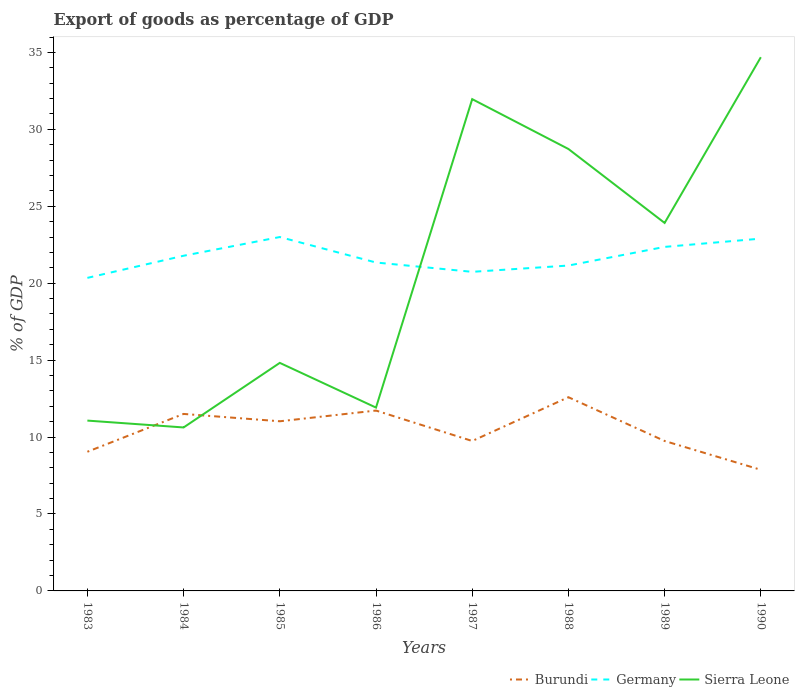How many different coloured lines are there?
Your answer should be compact. 3. Across all years, what is the maximum export of goods as percentage of GDP in Burundi?
Offer a very short reply. 7.87. In which year was the export of goods as percentage of GDP in Burundi maximum?
Your answer should be compact. 1990. What is the total export of goods as percentage of GDP in Germany in the graph?
Keep it short and to the point. -0.58. What is the difference between the highest and the second highest export of goods as percentage of GDP in Sierra Leone?
Provide a succinct answer. 24.07. Is the export of goods as percentage of GDP in Sierra Leone strictly greater than the export of goods as percentage of GDP in Burundi over the years?
Give a very brief answer. No. How many years are there in the graph?
Provide a succinct answer. 8. What is the title of the graph?
Your answer should be very brief. Export of goods as percentage of GDP. Does "Luxembourg" appear as one of the legend labels in the graph?
Ensure brevity in your answer.  No. What is the label or title of the Y-axis?
Provide a short and direct response. % of GDP. What is the % of GDP of Burundi in 1983?
Your answer should be compact. 9.05. What is the % of GDP of Germany in 1983?
Give a very brief answer. 20.35. What is the % of GDP in Sierra Leone in 1983?
Offer a very short reply. 11.07. What is the % of GDP of Burundi in 1984?
Provide a short and direct response. 11.5. What is the % of GDP of Germany in 1984?
Provide a succinct answer. 21.79. What is the % of GDP in Sierra Leone in 1984?
Make the answer very short. 10.62. What is the % of GDP of Burundi in 1985?
Give a very brief answer. 11.03. What is the % of GDP in Germany in 1985?
Your answer should be compact. 23. What is the % of GDP of Sierra Leone in 1985?
Ensure brevity in your answer.  14.82. What is the % of GDP in Burundi in 1986?
Offer a very short reply. 11.72. What is the % of GDP of Germany in 1986?
Your answer should be very brief. 21.35. What is the % of GDP in Sierra Leone in 1986?
Your answer should be very brief. 11.92. What is the % of GDP of Burundi in 1987?
Ensure brevity in your answer.  9.74. What is the % of GDP in Germany in 1987?
Provide a short and direct response. 20.74. What is the % of GDP of Sierra Leone in 1987?
Keep it short and to the point. 31.96. What is the % of GDP of Burundi in 1988?
Your answer should be very brief. 12.59. What is the % of GDP of Germany in 1988?
Offer a very short reply. 21.15. What is the % of GDP in Sierra Leone in 1988?
Your answer should be compact. 28.72. What is the % of GDP in Burundi in 1989?
Keep it short and to the point. 9.75. What is the % of GDP in Germany in 1989?
Your answer should be very brief. 22.36. What is the % of GDP of Sierra Leone in 1989?
Make the answer very short. 23.92. What is the % of GDP in Burundi in 1990?
Make the answer very short. 7.87. What is the % of GDP of Germany in 1990?
Provide a succinct answer. 22.9. What is the % of GDP in Sierra Leone in 1990?
Keep it short and to the point. 34.69. Across all years, what is the maximum % of GDP in Burundi?
Offer a very short reply. 12.59. Across all years, what is the maximum % of GDP of Germany?
Ensure brevity in your answer.  23. Across all years, what is the maximum % of GDP in Sierra Leone?
Ensure brevity in your answer.  34.69. Across all years, what is the minimum % of GDP in Burundi?
Provide a short and direct response. 7.87. Across all years, what is the minimum % of GDP of Germany?
Keep it short and to the point. 20.35. Across all years, what is the minimum % of GDP in Sierra Leone?
Give a very brief answer. 10.62. What is the total % of GDP in Burundi in the graph?
Offer a terse response. 83.25. What is the total % of GDP in Germany in the graph?
Ensure brevity in your answer.  173.63. What is the total % of GDP in Sierra Leone in the graph?
Keep it short and to the point. 167.73. What is the difference between the % of GDP of Burundi in 1983 and that in 1984?
Provide a succinct answer. -2.46. What is the difference between the % of GDP of Germany in 1983 and that in 1984?
Your response must be concise. -1.44. What is the difference between the % of GDP in Sierra Leone in 1983 and that in 1984?
Your response must be concise. 0.45. What is the difference between the % of GDP in Burundi in 1983 and that in 1985?
Make the answer very short. -1.98. What is the difference between the % of GDP in Germany in 1983 and that in 1985?
Offer a very short reply. -2.65. What is the difference between the % of GDP of Sierra Leone in 1983 and that in 1985?
Provide a succinct answer. -3.75. What is the difference between the % of GDP of Burundi in 1983 and that in 1986?
Give a very brief answer. -2.68. What is the difference between the % of GDP of Germany in 1983 and that in 1986?
Offer a very short reply. -1. What is the difference between the % of GDP in Sierra Leone in 1983 and that in 1986?
Keep it short and to the point. -0.85. What is the difference between the % of GDP of Burundi in 1983 and that in 1987?
Offer a very short reply. -0.7. What is the difference between the % of GDP in Germany in 1983 and that in 1987?
Offer a very short reply. -0.39. What is the difference between the % of GDP in Sierra Leone in 1983 and that in 1987?
Make the answer very short. -20.89. What is the difference between the % of GDP in Burundi in 1983 and that in 1988?
Your response must be concise. -3.55. What is the difference between the % of GDP in Germany in 1983 and that in 1988?
Your response must be concise. -0.8. What is the difference between the % of GDP in Sierra Leone in 1983 and that in 1988?
Offer a terse response. -17.65. What is the difference between the % of GDP in Burundi in 1983 and that in 1989?
Ensure brevity in your answer.  -0.7. What is the difference between the % of GDP in Germany in 1983 and that in 1989?
Offer a very short reply. -2.01. What is the difference between the % of GDP of Sierra Leone in 1983 and that in 1989?
Offer a very short reply. -12.85. What is the difference between the % of GDP in Burundi in 1983 and that in 1990?
Offer a very short reply. 1.17. What is the difference between the % of GDP in Germany in 1983 and that in 1990?
Offer a very short reply. -2.55. What is the difference between the % of GDP in Sierra Leone in 1983 and that in 1990?
Your response must be concise. -23.62. What is the difference between the % of GDP of Burundi in 1984 and that in 1985?
Offer a very short reply. 0.48. What is the difference between the % of GDP in Germany in 1984 and that in 1985?
Offer a terse response. -1.22. What is the difference between the % of GDP in Sierra Leone in 1984 and that in 1985?
Your answer should be compact. -4.2. What is the difference between the % of GDP in Burundi in 1984 and that in 1986?
Keep it short and to the point. -0.22. What is the difference between the % of GDP of Germany in 1984 and that in 1986?
Ensure brevity in your answer.  0.44. What is the difference between the % of GDP of Sierra Leone in 1984 and that in 1986?
Keep it short and to the point. -1.29. What is the difference between the % of GDP in Burundi in 1984 and that in 1987?
Make the answer very short. 1.76. What is the difference between the % of GDP in Germany in 1984 and that in 1987?
Offer a very short reply. 1.05. What is the difference between the % of GDP of Sierra Leone in 1984 and that in 1987?
Your answer should be compact. -21.34. What is the difference between the % of GDP in Burundi in 1984 and that in 1988?
Make the answer very short. -1.09. What is the difference between the % of GDP of Germany in 1984 and that in 1988?
Your answer should be compact. 0.64. What is the difference between the % of GDP of Sierra Leone in 1984 and that in 1988?
Your answer should be compact. -18.1. What is the difference between the % of GDP of Burundi in 1984 and that in 1989?
Provide a succinct answer. 1.76. What is the difference between the % of GDP of Germany in 1984 and that in 1989?
Your answer should be very brief. -0.58. What is the difference between the % of GDP in Sierra Leone in 1984 and that in 1989?
Keep it short and to the point. -13.29. What is the difference between the % of GDP of Burundi in 1984 and that in 1990?
Your response must be concise. 3.63. What is the difference between the % of GDP of Germany in 1984 and that in 1990?
Ensure brevity in your answer.  -1.11. What is the difference between the % of GDP of Sierra Leone in 1984 and that in 1990?
Provide a succinct answer. -24.07. What is the difference between the % of GDP of Burundi in 1985 and that in 1986?
Provide a succinct answer. -0.7. What is the difference between the % of GDP of Germany in 1985 and that in 1986?
Make the answer very short. 1.66. What is the difference between the % of GDP in Sierra Leone in 1985 and that in 1986?
Your answer should be compact. 2.91. What is the difference between the % of GDP in Burundi in 1985 and that in 1987?
Ensure brevity in your answer.  1.28. What is the difference between the % of GDP of Germany in 1985 and that in 1987?
Offer a terse response. 2.26. What is the difference between the % of GDP of Sierra Leone in 1985 and that in 1987?
Your response must be concise. -17.14. What is the difference between the % of GDP in Burundi in 1985 and that in 1988?
Give a very brief answer. -1.56. What is the difference between the % of GDP of Germany in 1985 and that in 1988?
Keep it short and to the point. 1.85. What is the difference between the % of GDP in Sierra Leone in 1985 and that in 1988?
Your response must be concise. -13.9. What is the difference between the % of GDP of Burundi in 1985 and that in 1989?
Your answer should be very brief. 1.28. What is the difference between the % of GDP in Germany in 1985 and that in 1989?
Your answer should be compact. 0.64. What is the difference between the % of GDP of Sierra Leone in 1985 and that in 1989?
Give a very brief answer. -9.1. What is the difference between the % of GDP in Burundi in 1985 and that in 1990?
Keep it short and to the point. 3.15. What is the difference between the % of GDP of Germany in 1985 and that in 1990?
Give a very brief answer. 0.1. What is the difference between the % of GDP in Sierra Leone in 1985 and that in 1990?
Your answer should be compact. -19.87. What is the difference between the % of GDP of Burundi in 1986 and that in 1987?
Keep it short and to the point. 1.98. What is the difference between the % of GDP of Germany in 1986 and that in 1987?
Ensure brevity in your answer.  0.61. What is the difference between the % of GDP in Sierra Leone in 1986 and that in 1987?
Your answer should be very brief. -20.05. What is the difference between the % of GDP in Burundi in 1986 and that in 1988?
Ensure brevity in your answer.  -0.87. What is the difference between the % of GDP of Germany in 1986 and that in 1988?
Your answer should be compact. 0.2. What is the difference between the % of GDP in Sierra Leone in 1986 and that in 1988?
Keep it short and to the point. -16.81. What is the difference between the % of GDP of Burundi in 1986 and that in 1989?
Make the answer very short. 1.98. What is the difference between the % of GDP in Germany in 1986 and that in 1989?
Your answer should be very brief. -1.02. What is the difference between the % of GDP of Sierra Leone in 1986 and that in 1989?
Offer a terse response. -12. What is the difference between the % of GDP of Burundi in 1986 and that in 1990?
Your response must be concise. 3.85. What is the difference between the % of GDP in Germany in 1986 and that in 1990?
Ensure brevity in your answer.  -1.55. What is the difference between the % of GDP of Sierra Leone in 1986 and that in 1990?
Ensure brevity in your answer.  -22.77. What is the difference between the % of GDP in Burundi in 1987 and that in 1988?
Provide a short and direct response. -2.85. What is the difference between the % of GDP in Germany in 1987 and that in 1988?
Offer a very short reply. -0.41. What is the difference between the % of GDP in Sierra Leone in 1987 and that in 1988?
Make the answer very short. 3.24. What is the difference between the % of GDP in Burundi in 1987 and that in 1989?
Keep it short and to the point. -0. What is the difference between the % of GDP in Germany in 1987 and that in 1989?
Your answer should be very brief. -1.62. What is the difference between the % of GDP in Sierra Leone in 1987 and that in 1989?
Ensure brevity in your answer.  8.05. What is the difference between the % of GDP of Burundi in 1987 and that in 1990?
Your answer should be very brief. 1.87. What is the difference between the % of GDP in Germany in 1987 and that in 1990?
Your answer should be compact. -2.16. What is the difference between the % of GDP of Sierra Leone in 1987 and that in 1990?
Your answer should be very brief. -2.73. What is the difference between the % of GDP in Burundi in 1988 and that in 1989?
Ensure brevity in your answer.  2.85. What is the difference between the % of GDP of Germany in 1988 and that in 1989?
Offer a very short reply. -1.21. What is the difference between the % of GDP in Sierra Leone in 1988 and that in 1989?
Your response must be concise. 4.81. What is the difference between the % of GDP in Burundi in 1988 and that in 1990?
Give a very brief answer. 4.72. What is the difference between the % of GDP of Germany in 1988 and that in 1990?
Offer a terse response. -1.75. What is the difference between the % of GDP of Sierra Leone in 1988 and that in 1990?
Give a very brief answer. -5.97. What is the difference between the % of GDP of Burundi in 1989 and that in 1990?
Make the answer very short. 1.87. What is the difference between the % of GDP in Germany in 1989 and that in 1990?
Your response must be concise. -0.54. What is the difference between the % of GDP of Sierra Leone in 1989 and that in 1990?
Provide a succinct answer. -10.77. What is the difference between the % of GDP of Burundi in 1983 and the % of GDP of Germany in 1984?
Your response must be concise. -12.74. What is the difference between the % of GDP of Burundi in 1983 and the % of GDP of Sierra Leone in 1984?
Offer a terse response. -1.58. What is the difference between the % of GDP in Germany in 1983 and the % of GDP in Sierra Leone in 1984?
Offer a terse response. 9.72. What is the difference between the % of GDP of Burundi in 1983 and the % of GDP of Germany in 1985?
Offer a very short reply. -13.96. What is the difference between the % of GDP in Burundi in 1983 and the % of GDP in Sierra Leone in 1985?
Keep it short and to the point. -5.78. What is the difference between the % of GDP of Germany in 1983 and the % of GDP of Sierra Leone in 1985?
Your answer should be compact. 5.52. What is the difference between the % of GDP of Burundi in 1983 and the % of GDP of Sierra Leone in 1986?
Keep it short and to the point. -2.87. What is the difference between the % of GDP of Germany in 1983 and the % of GDP of Sierra Leone in 1986?
Offer a very short reply. 8.43. What is the difference between the % of GDP of Burundi in 1983 and the % of GDP of Germany in 1987?
Keep it short and to the point. -11.69. What is the difference between the % of GDP in Burundi in 1983 and the % of GDP in Sierra Leone in 1987?
Make the answer very short. -22.92. What is the difference between the % of GDP of Germany in 1983 and the % of GDP of Sierra Leone in 1987?
Offer a very short reply. -11.62. What is the difference between the % of GDP of Burundi in 1983 and the % of GDP of Germany in 1988?
Provide a succinct answer. -12.1. What is the difference between the % of GDP of Burundi in 1983 and the % of GDP of Sierra Leone in 1988?
Your answer should be compact. -19.68. What is the difference between the % of GDP of Germany in 1983 and the % of GDP of Sierra Leone in 1988?
Give a very brief answer. -8.38. What is the difference between the % of GDP in Burundi in 1983 and the % of GDP in Germany in 1989?
Give a very brief answer. -13.32. What is the difference between the % of GDP of Burundi in 1983 and the % of GDP of Sierra Leone in 1989?
Keep it short and to the point. -14.87. What is the difference between the % of GDP of Germany in 1983 and the % of GDP of Sierra Leone in 1989?
Give a very brief answer. -3.57. What is the difference between the % of GDP of Burundi in 1983 and the % of GDP of Germany in 1990?
Make the answer very short. -13.85. What is the difference between the % of GDP of Burundi in 1983 and the % of GDP of Sierra Leone in 1990?
Your response must be concise. -25.64. What is the difference between the % of GDP of Germany in 1983 and the % of GDP of Sierra Leone in 1990?
Your answer should be compact. -14.34. What is the difference between the % of GDP of Burundi in 1984 and the % of GDP of Germany in 1985?
Offer a very short reply. -11.5. What is the difference between the % of GDP in Burundi in 1984 and the % of GDP in Sierra Leone in 1985?
Offer a very short reply. -3.32. What is the difference between the % of GDP of Germany in 1984 and the % of GDP of Sierra Leone in 1985?
Offer a very short reply. 6.96. What is the difference between the % of GDP in Burundi in 1984 and the % of GDP in Germany in 1986?
Provide a short and direct response. -9.84. What is the difference between the % of GDP in Burundi in 1984 and the % of GDP in Sierra Leone in 1986?
Your answer should be very brief. -0.41. What is the difference between the % of GDP in Germany in 1984 and the % of GDP in Sierra Leone in 1986?
Make the answer very short. 9.87. What is the difference between the % of GDP in Burundi in 1984 and the % of GDP in Germany in 1987?
Make the answer very short. -9.24. What is the difference between the % of GDP of Burundi in 1984 and the % of GDP of Sierra Leone in 1987?
Offer a terse response. -20.46. What is the difference between the % of GDP of Germany in 1984 and the % of GDP of Sierra Leone in 1987?
Your answer should be very brief. -10.18. What is the difference between the % of GDP of Burundi in 1984 and the % of GDP of Germany in 1988?
Your response must be concise. -9.64. What is the difference between the % of GDP in Burundi in 1984 and the % of GDP in Sierra Leone in 1988?
Make the answer very short. -17.22. What is the difference between the % of GDP in Germany in 1984 and the % of GDP in Sierra Leone in 1988?
Your answer should be very brief. -6.94. What is the difference between the % of GDP in Burundi in 1984 and the % of GDP in Germany in 1989?
Offer a very short reply. -10.86. What is the difference between the % of GDP of Burundi in 1984 and the % of GDP of Sierra Leone in 1989?
Your response must be concise. -12.41. What is the difference between the % of GDP in Germany in 1984 and the % of GDP in Sierra Leone in 1989?
Keep it short and to the point. -2.13. What is the difference between the % of GDP of Burundi in 1984 and the % of GDP of Germany in 1990?
Provide a short and direct response. -11.39. What is the difference between the % of GDP of Burundi in 1984 and the % of GDP of Sierra Leone in 1990?
Your answer should be compact. -23.19. What is the difference between the % of GDP in Germany in 1984 and the % of GDP in Sierra Leone in 1990?
Your answer should be compact. -12.9. What is the difference between the % of GDP of Burundi in 1985 and the % of GDP of Germany in 1986?
Your answer should be compact. -10.32. What is the difference between the % of GDP of Burundi in 1985 and the % of GDP of Sierra Leone in 1986?
Your response must be concise. -0.89. What is the difference between the % of GDP of Germany in 1985 and the % of GDP of Sierra Leone in 1986?
Offer a terse response. 11.09. What is the difference between the % of GDP of Burundi in 1985 and the % of GDP of Germany in 1987?
Offer a terse response. -9.71. What is the difference between the % of GDP of Burundi in 1985 and the % of GDP of Sierra Leone in 1987?
Your response must be concise. -20.94. What is the difference between the % of GDP of Germany in 1985 and the % of GDP of Sierra Leone in 1987?
Keep it short and to the point. -8.96. What is the difference between the % of GDP in Burundi in 1985 and the % of GDP in Germany in 1988?
Make the answer very short. -10.12. What is the difference between the % of GDP of Burundi in 1985 and the % of GDP of Sierra Leone in 1988?
Provide a succinct answer. -17.7. What is the difference between the % of GDP of Germany in 1985 and the % of GDP of Sierra Leone in 1988?
Your response must be concise. -5.72. What is the difference between the % of GDP of Burundi in 1985 and the % of GDP of Germany in 1989?
Keep it short and to the point. -11.33. What is the difference between the % of GDP of Burundi in 1985 and the % of GDP of Sierra Leone in 1989?
Offer a very short reply. -12.89. What is the difference between the % of GDP of Germany in 1985 and the % of GDP of Sierra Leone in 1989?
Your answer should be very brief. -0.92. What is the difference between the % of GDP of Burundi in 1985 and the % of GDP of Germany in 1990?
Your answer should be very brief. -11.87. What is the difference between the % of GDP in Burundi in 1985 and the % of GDP in Sierra Leone in 1990?
Keep it short and to the point. -23.66. What is the difference between the % of GDP of Germany in 1985 and the % of GDP of Sierra Leone in 1990?
Make the answer very short. -11.69. What is the difference between the % of GDP in Burundi in 1986 and the % of GDP in Germany in 1987?
Ensure brevity in your answer.  -9.02. What is the difference between the % of GDP in Burundi in 1986 and the % of GDP in Sierra Leone in 1987?
Your answer should be compact. -20.24. What is the difference between the % of GDP of Germany in 1986 and the % of GDP of Sierra Leone in 1987?
Provide a short and direct response. -10.62. What is the difference between the % of GDP in Burundi in 1986 and the % of GDP in Germany in 1988?
Provide a short and direct response. -9.42. What is the difference between the % of GDP of Burundi in 1986 and the % of GDP of Sierra Leone in 1988?
Give a very brief answer. -17. What is the difference between the % of GDP of Germany in 1986 and the % of GDP of Sierra Leone in 1988?
Provide a succinct answer. -7.38. What is the difference between the % of GDP in Burundi in 1986 and the % of GDP in Germany in 1989?
Offer a terse response. -10.64. What is the difference between the % of GDP of Burundi in 1986 and the % of GDP of Sierra Leone in 1989?
Your answer should be compact. -12.19. What is the difference between the % of GDP in Germany in 1986 and the % of GDP in Sierra Leone in 1989?
Give a very brief answer. -2.57. What is the difference between the % of GDP of Burundi in 1986 and the % of GDP of Germany in 1990?
Give a very brief answer. -11.18. What is the difference between the % of GDP of Burundi in 1986 and the % of GDP of Sierra Leone in 1990?
Provide a succinct answer. -22.97. What is the difference between the % of GDP of Germany in 1986 and the % of GDP of Sierra Leone in 1990?
Provide a short and direct response. -13.34. What is the difference between the % of GDP of Burundi in 1987 and the % of GDP of Germany in 1988?
Your response must be concise. -11.4. What is the difference between the % of GDP of Burundi in 1987 and the % of GDP of Sierra Leone in 1988?
Provide a succinct answer. -18.98. What is the difference between the % of GDP in Germany in 1987 and the % of GDP in Sierra Leone in 1988?
Make the answer very short. -7.98. What is the difference between the % of GDP in Burundi in 1987 and the % of GDP in Germany in 1989?
Your answer should be very brief. -12.62. What is the difference between the % of GDP in Burundi in 1987 and the % of GDP in Sierra Leone in 1989?
Make the answer very short. -14.17. What is the difference between the % of GDP in Germany in 1987 and the % of GDP in Sierra Leone in 1989?
Offer a terse response. -3.18. What is the difference between the % of GDP in Burundi in 1987 and the % of GDP in Germany in 1990?
Offer a terse response. -13.15. What is the difference between the % of GDP in Burundi in 1987 and the % of GDP in Sierra Leone in 1990?
Provide a short and direct response. -24.95. What is the difference between the % of GDP of Germany in 1987 and the % of GDP of Sierra Leone in 1990?
Offer a very short reply. -13.95. What is the difference between the % of GDP of Burundi in 1988 and the % of GDP of Germany in 1989?
Keep it short and to the point. -9.77. What is the difference between the % of GDP in Burundi in 1988 and the % of GDP in Sierra Leone in 1989?
Your answer should be compact. -11.33. What is the difference between the % of GDP of Germany in 1988 and the % of GDP of Sierra Leone in 1989?
Make the answer very short. -2.77. What is the difference between the % of GDP of Burundi in 1988 and the % of GDP of Germany in 1990?
Give a very brief answer. -10.31. What is the difference between the % of GDP of Burundi in 1988 and the % of GDP of Sierra Leone in 1990?
Your answer should be very brief. -22.1. What is the difference between the % of GDP of Germany in 1988 and the % of GDP of Sierra Leone in 1990?
Offer a terse response. -13.54. What is the difference between the % of GDP of Burundi in 1989 and the % of GDP of Germany in 1990?
Your answer should be compact. -13.15. What is the difference between the % of GDP in Burundi in 1989 and the % of GDP in Sierra Leone in 1990?
Your answer should be compact. -24.94. What is the difference between the % of GDP of Germany in 1989 and the % of GDP of Sierra Leone in 1990?
Give a very brief answer. -12.33. What is the average % of GDP in Burundi per year?
Your answer should be very brief. 10.41. What is the average % of GDP of Germany per year?
Your answer should be very brief. 21.7. What is the average % of GDP of Sierra Leone per year?
Keep it short and to the point. 20.97. In the year 1983, what is the difference between the % of GDP of Burundi and % of GDP of Germany?
Your answer should be very brief. -11.3. In the year 1983, what is the difference between the % of GDP in Burundi and % of GDP in Sierra Leone?
Your answer should be compact. -2.03. In the year 1983, what is the difference between the % of GDP of Germany and % of GDP of Sierra Leone?
Keep it short and to the point. 9.28. In the year 1984, what is the difference between the % of GDP in Burundi and % of GDP in Germany?
Your answer should be compact. -10.28. In the year 1984, what is the difference between the % of GDP of Burundi and % of GDP of Sierra Leone?
Provide a short and direct response. 0.88. In the year 1984, what is the difference between the % of GDP of Germany and % of GDP of Sierra Leone?
Provide a succinct answer. 11.16. In the year 1985, what is the difference between the % of GDP in Burundi and % of GDP in Germany?
Offer a terse response. -11.98. In the year 1985, what is the difference between the % of GDP of Burundi and % of GDP of Sierra Leone?
Your answer should be compact. -3.8. In the year 1985, what is the difference between the % of GDP of Germany and % of GDP of Sierra Leone?
Your answer should be compact. 8.18. In the year 1986, what is the difference between the % of GDP of Burundi and % of GDP of Germany?
Offer a very short reply. -9.62. In the year 1986, what is the difference between the % of GDP in Burundi and % of GDP in Sierra Leone?
Give a very brief answer. -0.19. In the year 1986, what is the difference between the % of GDP in Germany and % of GDP in Sierra Leone?
Offer a very short reply. 9.43. In the year 1987, what is the difference between the % of GDP of Burundi and % of GDP of Germany?
Give a very brief answer. -10.99. In the year 1987, what is the difference between the % of GDP in Burundi and % of GDP in Sierra Leone?
Offer a terse response. -22.22. In the year 1987, what is the difference between the % of GDP in Germany and % of GDP in Sierra Leone?
Offer a terse response. -11.22. In the year 1988, what is the difference between the % of GDP of Burundi and % of GDP of Germany?
Ensure brevity in your answer.  -8.56. In the year 1988, what is the difference between the % of GDP of Burundi and % of GDP of Sierra Leone?
Provide a succinct answer. -16.13. In the year 1988, what is the difference between the % of GDP in Germany and % of GDP in Sierra Leone?
Your response must be concise. -7.58. In the year 1989, what is the difference between the % of GDP in Burundi and % of GDP in Germany?
Provide a succinct answer. -12.62. In the year 1989, what is the difference between the % of GDP of Burundi and % of GDP of Sierra Leone?
Give a very brief answer. -14.17. In the year 1989, what is the difference between the % of GDP of Germany and % of GDP of Sierra Leone?
Give a very brief answer. -1.56. In the year 1990, what is the difference between the % of GDP of Burundi and % of GDP of Germany?
Offer a terse response. -15.03. In the year 1990, what is the difference between the % of GDP of Burundi and % of GDP of Sierra Leone?
Your response must be concise. -26.82. In the year 1990, what is the difference between the % of GDP in Germany and % of GDP in Sierra Leone?
Keep it short and to the point. -11.79. What is the ratio of the % of GDP in Burundi in 1983 to that in 1984?
Ensure brevity in your answer.  0.79. What is the ratio of the % of GDP in Germany in 1983 to that in 1984?
Keep it short and to the point. 0.93. What is the ratio of the % of GDP of Sierra Leone in 1983 to that in 1984?
Ensure brevity in your answer.  1.04. What is the ratio of the % of GDP of Burundi in 1983 to that in 1985?
Your answer should be very brief. 0.82. What is the ratio of the % of GDP in Germany in 1983 to that in 1985?
Keep it short and to the point. 0.88. What is the ratio of the % of GDP of Sierra Leone in 1983 to that in 1985?
Provide a short and direct response. 0.75. What is the ratio of the % of GDP in Burundi in 1983 to that in 1986?
Your answer should be compact. 0.77. What is the ratio of the % of GDP in Germany in 1983 to that in 1986?
Offer a very short reply. 0.95. What is the ratio of the % of GDP in Sierra Leone in 1983 to that in 1986?
Make the answer very short. 0.93. What is the ratio of the % of GDP of Burundi in 1983 to that in 1987?
Offer a terse response. 0.93. What is the ratio of the % of GDP of Germany in 1983 to that in 1987?
Keep it short and to the point. 0.98. What is the ratio of the % of GDP of Sierra Leone in 1983 to that in 1987?
Your answer should be very brief. 0.35. What is the ratio of the % of GDP of Burundi in 1983 to that in 1988?
Offer a terse response. 0.72. What is the ratio of the % of GDP of Germany in 1983 to that in 1988?
Offer a terse response. 0.96. What is the ratio of the % of GDP of Sierra Leone in 1983 to that in 1988?
Your answer should be compact. 0.39. What is the ratio of the % of GDP of Burundi in 1983 to that in 1989?
Your answer should be very brief. 0.93. What is the ratio of the % of GDP of Germany in 1983 to that in 1989?
Offer a terse response. 0.91. What is the ratio of the % of GDP in Sierra Leone in 1983 to that in 1989?
Offer a terse response. 0.46. What is the ratio of the % of GDP of Burundi in 1983 to that in 1990?
Give a very brief answer. 1.15. What is the ratio of the % of GDP in Germany in 1983 to that in 1990?
Offer a very short reply. 0.89. What is the ratio of the % of GDP of Sierra Leone in 1983 to that in 1990?
Ensure brevity in your answer.  0.32. What is the ratio of the % of GDP in Burundi in 1984 to that in 1985?
Your answer should be very brief. 1.04. What is the ratio of the % of GDP of Germany in 1984 to that in 1985?
Your answer should be compact. 0.95. What is the ratio of the % of GDP of Sierra Leone in 1984 to that in 1985?
Offer a terse response. 0.72. What is the ratio of the % of GDP of Burundi in 1984 to that in 1986?
Provide a short and direct response. 0.98. What is the ratio of the % of GDP of Germany in 1984 to that in 1986?
Offer a very short reply. 1.02. What is the ratio of the % of GDP in Sierra Leone in 1984 to that in 1986?
Ensure brevity in your answer.  0.89. What is the ratio of the % of GDP in Burundi in 1984 to that in 1987?
Your answer should be compact. 1.18. What is the ratio of the % of GDP in Germany in 1984 to that in 1987?
Your answer should be compact. 1.05. What is the ratio of the % of GDP of Sierra Leone in 1984 to that in 1987?
Offer a terse response. 0.33. What is the ratio of the % of GDP in Burundi in 1984 to that in 1988?
Your response must be concise. 0.91. What is the ratio of the % of GDP of Germany in 1984 to that in 1988?
Make the answer very short. 1.03. What is the ratio of the % of GDP of Sierra Leone in 1984 to that in 1988?
Give a very brief answer. 0.37. What is the ratio of the % of GDP of Burundi in 1984 to that in 1989?
Offer a very short reply. 1.18. What is the ratio of the % of GDP in Germany in 1984 to that in 1989?
Keep it short and to the point. 0.97. What is the ratio of the % of GDP in Sierra Leone in 1984 to that in 1989?
Your answer should be compact. 0.44. What is the ratio of the % of GDP of Burundi in 1984 to that in 1990?
Make the answer very short. 1.46. What is the ratio of the % of GDP of Germany in 1984 to that in 1990?
Ensure brevity in your answer.  0.95. What is the ratio of the % of GDP of Sierra Leone in 1984 to that in 1990?
Provide a short and direct response. 0.31. What is the ratio of the % of GDP of Burundi in 1985 to that in 1986?
Provide a succinct answer. 0.94. What is the ratio of the % of GDP of Germany in 1985 to that in 1986?
Your response must be concise. 1.08. What is the ratio of the % of GDP of Sierra Leone in 1985 to that in 1986?
Keep it short and to the point. 1.24. What is the ratio of the % of GDP in Burundi in 1985 to that in 1987?
Offer a terse response. 1.13. What is the ratio of the % of GDP in Germany in 1985 to that in 1987?
Offer a very short reply. 1.11. What is the ratio of the % of GDP of Sierra Leone in 1985 to that in 1987?
Provide a short and direct response. 0.46. What is the ratio of the % of GDP in Burundi in 1985 to that in 1988?
Offer a terse response. 0.88. What is the ratio of the % of GDP in Germany in 1985 to that in 1988?
Your response must be concise. 1.09. What is the ratio of the % of GDP in Sierra Leone in 1985 to that in 1988?
Make the answer very short. 0.52. What is the ratio of the % of GDP in Burundi in 1985 to that in 1989?
Offer a terse response. 1.13. What is the ratio of the % of GDP in Germany in 1985 to that in 1989?
Provide a short and direct response. 1.03. What is the ratio of the % of GDP of Sierra Leone in 1985 to that in 1989?
Keep it short and to the point. 0.62. What is the ratio of the % of GDP in Burundi in 1985 to that in 1990?
Make the answer very short. 1.4. What is the ratio of the % of GDP of Sierra Leone in 1985 to that in 1990?
Offer a very short reply. 0.43. What is the ratio of the % of GDP of Burundi in 1986 to that in 1987?
Your answer should be very brief. 1.2. What is the ratio of the % of GDP of Germany in 1986 to that in 1987?
Provide a succinct answer. 1.03. What is the ratio of the % of GDP in Sierra Leone in 1986 to that in 1987?
Your answer should be very brief. 0.37. What is the ratio of the % of GDP in Burundi in 1986 to that in 1988?
Your answer should be very brief. 0.93. What is the ratio of the % of GDP in Germany in 1986 to that in 1988?
Provide a short and direct response. 1.01. What is the ratio of the % of GDP of Sierra Leone in 1986 to that in 1988?
Make the answer very short. 0.41. What is the ratio of the % of GDP of Burundi in 1986 to that in 1989?
Offer a terse response. 1.2. What is the ratio of the % of GDP of Germany in 1986 to that in 1989?
Offer a very short reply. 0.95. What is the ratio of the % of GDP in Sierra Leone in 1986 to that in 1989?
Provide a short and direct response. 0.5. What is the ratio of the % of GDP in Burundi in 1986 to that in 1990?
Ensure brevity in your answer.  1.49. What is the ratio of the % of GDP of Germany in 1986 to that in 1990?
Ensure brevity in your answer.  0.93. What is the ratio of the % of GDP of Sierra Leone in 1986 to that in 1990?
Ensure brevity in your answer.  0.34. What is the ratio of the % of GDP of Burundi in 1987 to that in 1988?
Give a very brief answer. 0.77. What is the ratio of the % of GDP of Germany in 1987 to that in 1988?
Offer a terse response. 0.98. What is the ratio of the % of GDP in Sierra Leone in 1987 to that in 1988?
Make the answer very short. 1.11. What is the ratio of the % of GDP in Burundi in 1987 to that in 1989?
Provide a succinct answer. 1. What is the ratio of the % of GDP in Germany in 1987 to that in 1989?
Offer a terse response. 0.93. What is the ratio of the % of GDP in Sierra Leone in 1987 to that in 1989?
Ensure brevity in your answer.  1.34. What is the ratio of the % of GDP of Burundi in 1987 to that in 1990?
Your response must be concise. 1.24. What is the ratio of the % of GDP in Germany in 1987 to that in 1990?
Offer a very short reply. 0.91. What is the ratio of the % of GDP in Sierra Leone in 1987 to that in 1990?
Give a very brief answer. 0.92. What is the ratio of the % of GDP in Burundi in 1988 to that in 1989?
Your response must be concise. 1.29. What is the ratio of the % of GDP in Germany in 1988 to that in 1989?
Your answer should be compact. 0.95. What is the ratio of the % of GDP of Sierra Leone in 1988 to that in 1989?
Offer a very short reply. 1.2. What is the ratio of the % of GDP of Burundi in 1988 to that in 1990?
Your response must be concise. 1.6. What is the ratio of the % of GDP of Germany in 1988 to that in 1990?
Give a very brief answer. 0.92. What is the ratio of the % of GDP of Sierra Leone in 1988 to that in 1990?
Give a very brief answer. 0.83. What is the ratio of the % of GDP of Burundi in 1989 to that in 1990?
Provide a succinct answer. 1.24. What is the ratio of the % of GDP of Germany in 1989 to that in 1990?
Your response must be concise. 0.98. What is the ratio of the % of GDP in Sierra Leone in 1989 to that in 1990?
Keep it short and to the point. 0.69. What is the difference between the highest and the second highest % of GDP in Burundi?
Provide a short and direct response. 0.87. What is the difference between the highest and the second highest % of GDP in Germany?
Your response must be concise. 0.1. What is the difference between the highest and the second highest % of GDP of Sierra Leone?
Your answer should be compact. 2.73. What is the difference between the highest and the lowest % of GDP of Burundi?
Offer a very short reply. 4.72. What is the difference between the highest and the lowest % of GDP in Germany?
Your response must be concise. 2.65. What is the difference between the highest and the lowest % of GDP of Sierra Leone?
Provide a short and direct response. 24.07. 